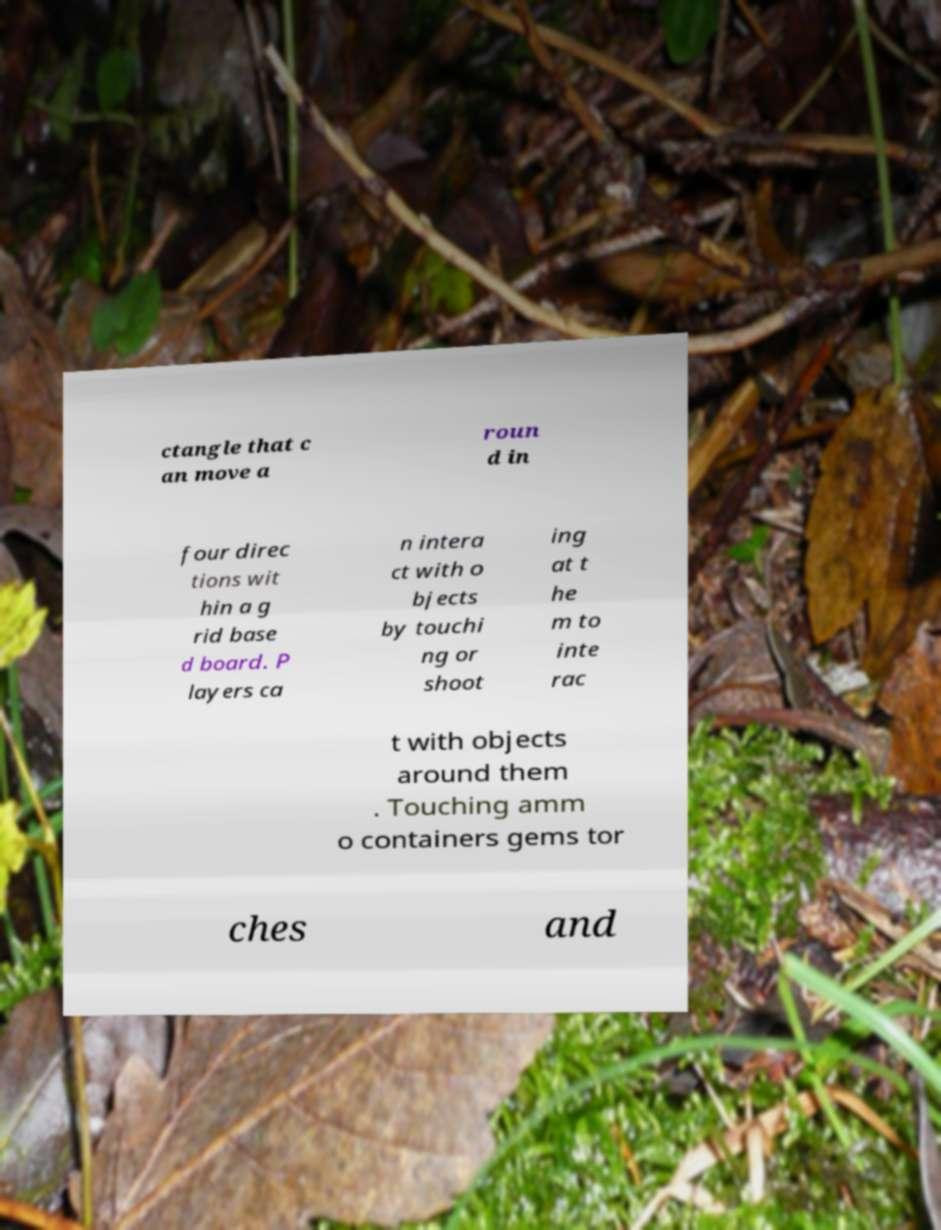For documentation purposes, I need the text within this image transcribed. Could you provide that? ctangle that c an move a roun d in four direc tions wit hin a g rid base d board. P layers ca n intera ct with o bjects by touchi ng or shoot ing at t he m to inte rac t with objects around them . Touching amm o containers gems tor ches and 